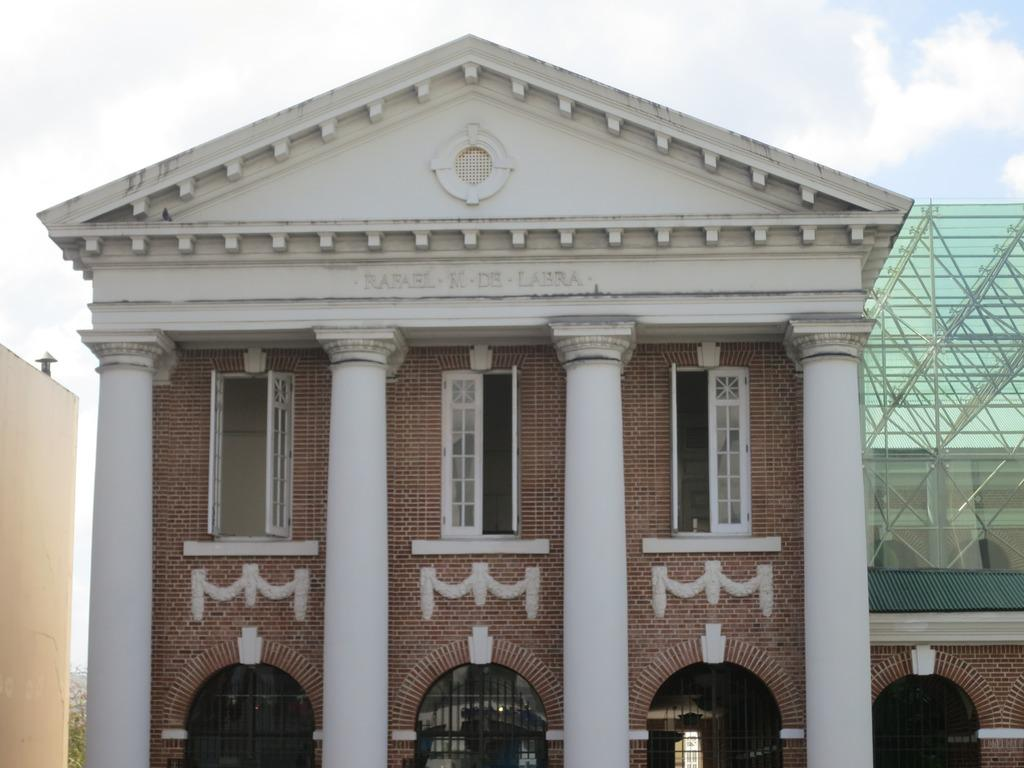What type of structure is visible in the image? There is a building in the image. What architectural features can be seen on the building? The building has windows, pillars, doors, and arches. What is visible at the top of the image? The sky is visible at the top of the image. What can be observed in the sky? There are clouds in the sky. Where is the market located in the image? There is no market present in the image; it features a building with various architectural features. What time of day is depicted in the image? The time of day cannot be determined from the image, as there is no specific indication of day or night. 